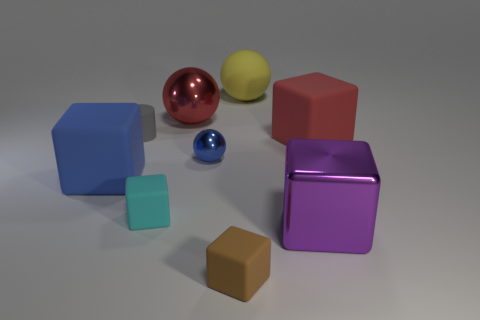Subtract all purple blocks. How many blocks are left? 4 Subtract all metallic blocks. How many blocks are left? 4 Subtract all green blocks. Subtract all cyan cylinders. How many blocks are left? 5 Add 1 big red rubber cylinders. How many objects exist? 10 Subtract all spheres. How many objects are left? 6 Subtract all yellow metallic cylinders. Subtract all tiny matte objects. How many objects are left? 6 Add 9 big metal balls. How many big metal balls are left? 10 Add 5 big green metal cylinders. How many big green metal cylinders exist? 5 Subtract 0 yellow cylinders. How many objects are left? 9 